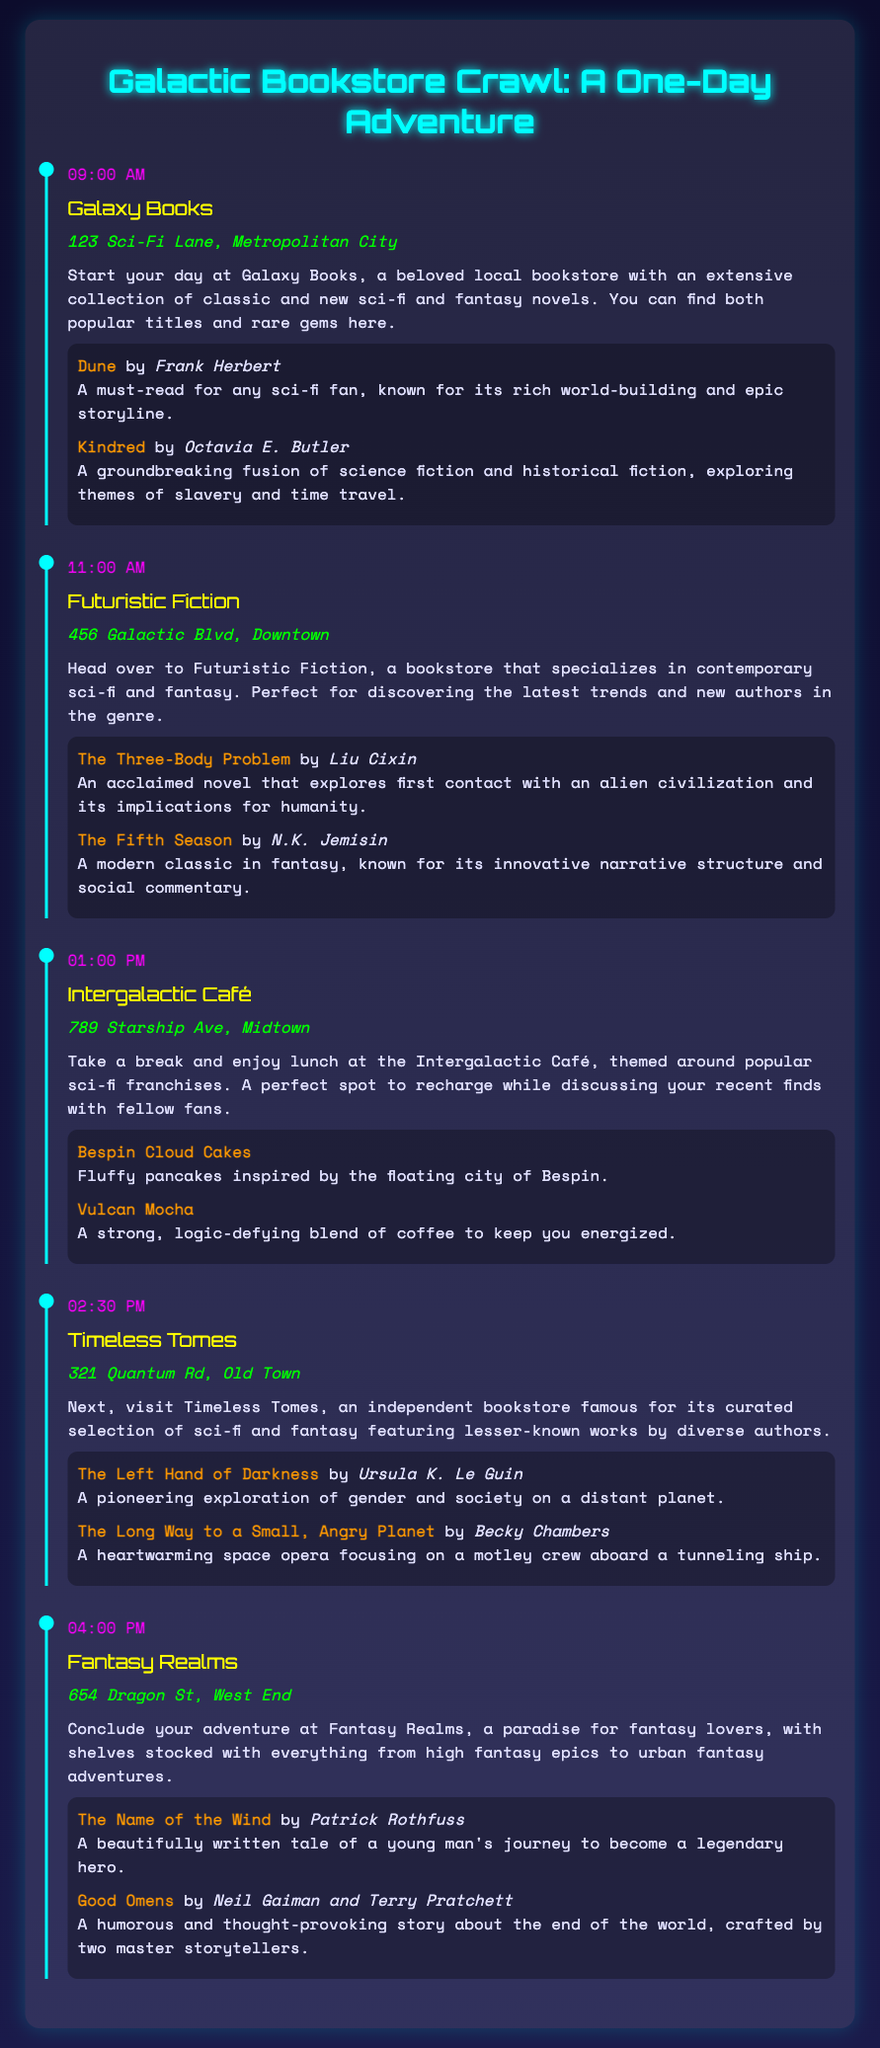What is the first stop on the bookstore crawl? The first stop is mentioned as Galaxy Books in the itinerary.
Answer: Galaxy Books At what time is lunch scheduled? The time for lunch is specified in the itinerary.
Answer: 01:00 PM Which book is recommended at Timeless Tomes? "The Left Hand of Darkness" is listed as a recommended book from Timeless Tomes.
Answer: The Left Hand of Darkness What kind of cuisine does the Intergalactic Café serve? The description of the Intergalactic Café hints at its sci-fi themed cuisine.
Answer: Sci-fi themed cuisine How many bookstores are included in the itinerary? The total number of stops is indicated throughout the document.
Answer: Five bookstores Which author wrote "The Name of the Wind"? The author of "The Name of the Wind" is mentioned in the recommended books section.
Answer: Patrick Rothfuss What is the location of Futuristic Fiction? The address of Futuristic Fiction is provided in the document.
Answer: 456 Galactic Blvd, Downtown List one suggested menu item at Intergalactic Café. The menu suggestions section provides specific names of menu items available.
Answer: Bespin Cloud Cakes Which bookstore specializes in contemporary sci-fi and fantasy? The description of a bookstore reveals its specialty in the document.
Answer: Futuristic Fiction 